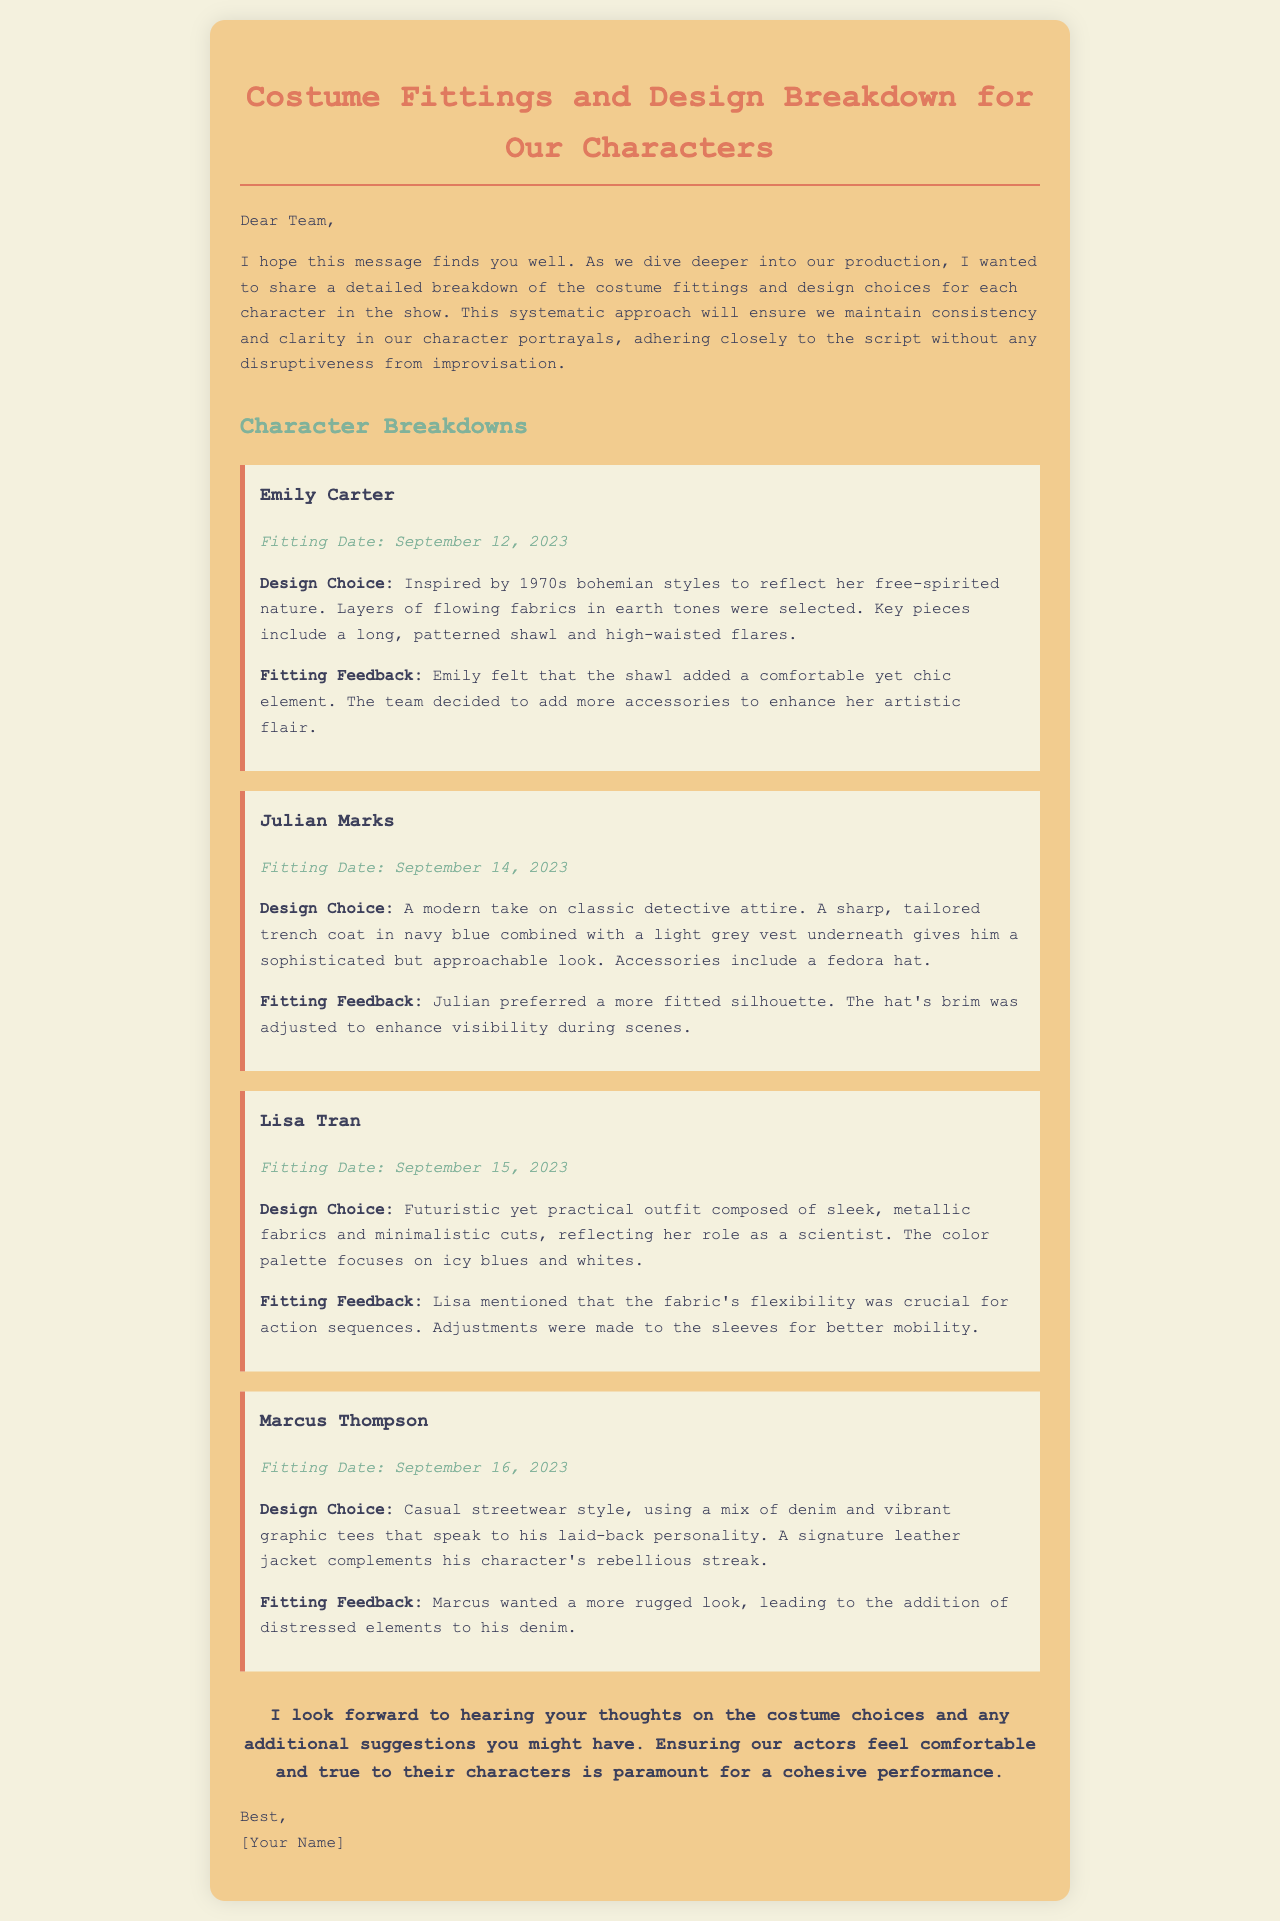What is the fitting date for Emily Carter? The fitting date for Emily Carter is specifically mentioned in the document.
Answer: September 12, 2023 What design choice is made for Julian Marks? The design choice for Julian Marks reflects his character's role and is described in the document.
Answer: A modern take on classic detective attire What color palette is used for Lisa Tran's costume? The color palette for Lisa Tran's costume is explicitly stated in the breakdown provided in the document.
Answer: Icy blues and whites What was added to Marcus's outfit to enhance his look? The document mentions the changes made to Marcus's outfit based on his feedback.
Answer: Distressed elements Which character's fitting feedback highlighted the need for better mobility? The character's fitting feedback included specific requests that are listed in the document.
Answer: Lisa Tran How does the fitting feedback for Julian highlights his preference? The fitting feedback for Julian details specific preferences regarding costume adjustments.
Answer: More fitted silhouette What type of style is associated with Marcus Thompson's character? The style associated with Marcus Thompson is described in the document, indicating his personality.
Answer: Casual streetwear style Who is the sender of the email? The sender of the email is mentioned at the end of the document.
Answer: [Your Name] 